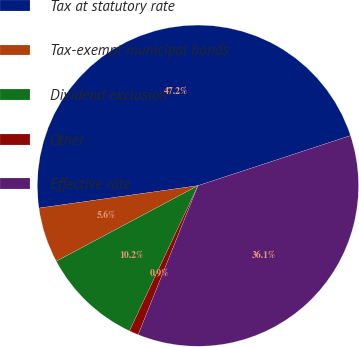Convert chart. <chart><loc_0><loc_0><loc_500><loc_500><pie_chart><fcel>Tax at statutory rate<fcel>Tax-exempt municipal bonds<fcel>Dividend exclusion<fcel>Other<fcel>Effective rate<nl><fcel>47.18%<fcel>5.57%<fcel>10.19%<fcel>0.94%<fcel>36.12%<nl></chart> 